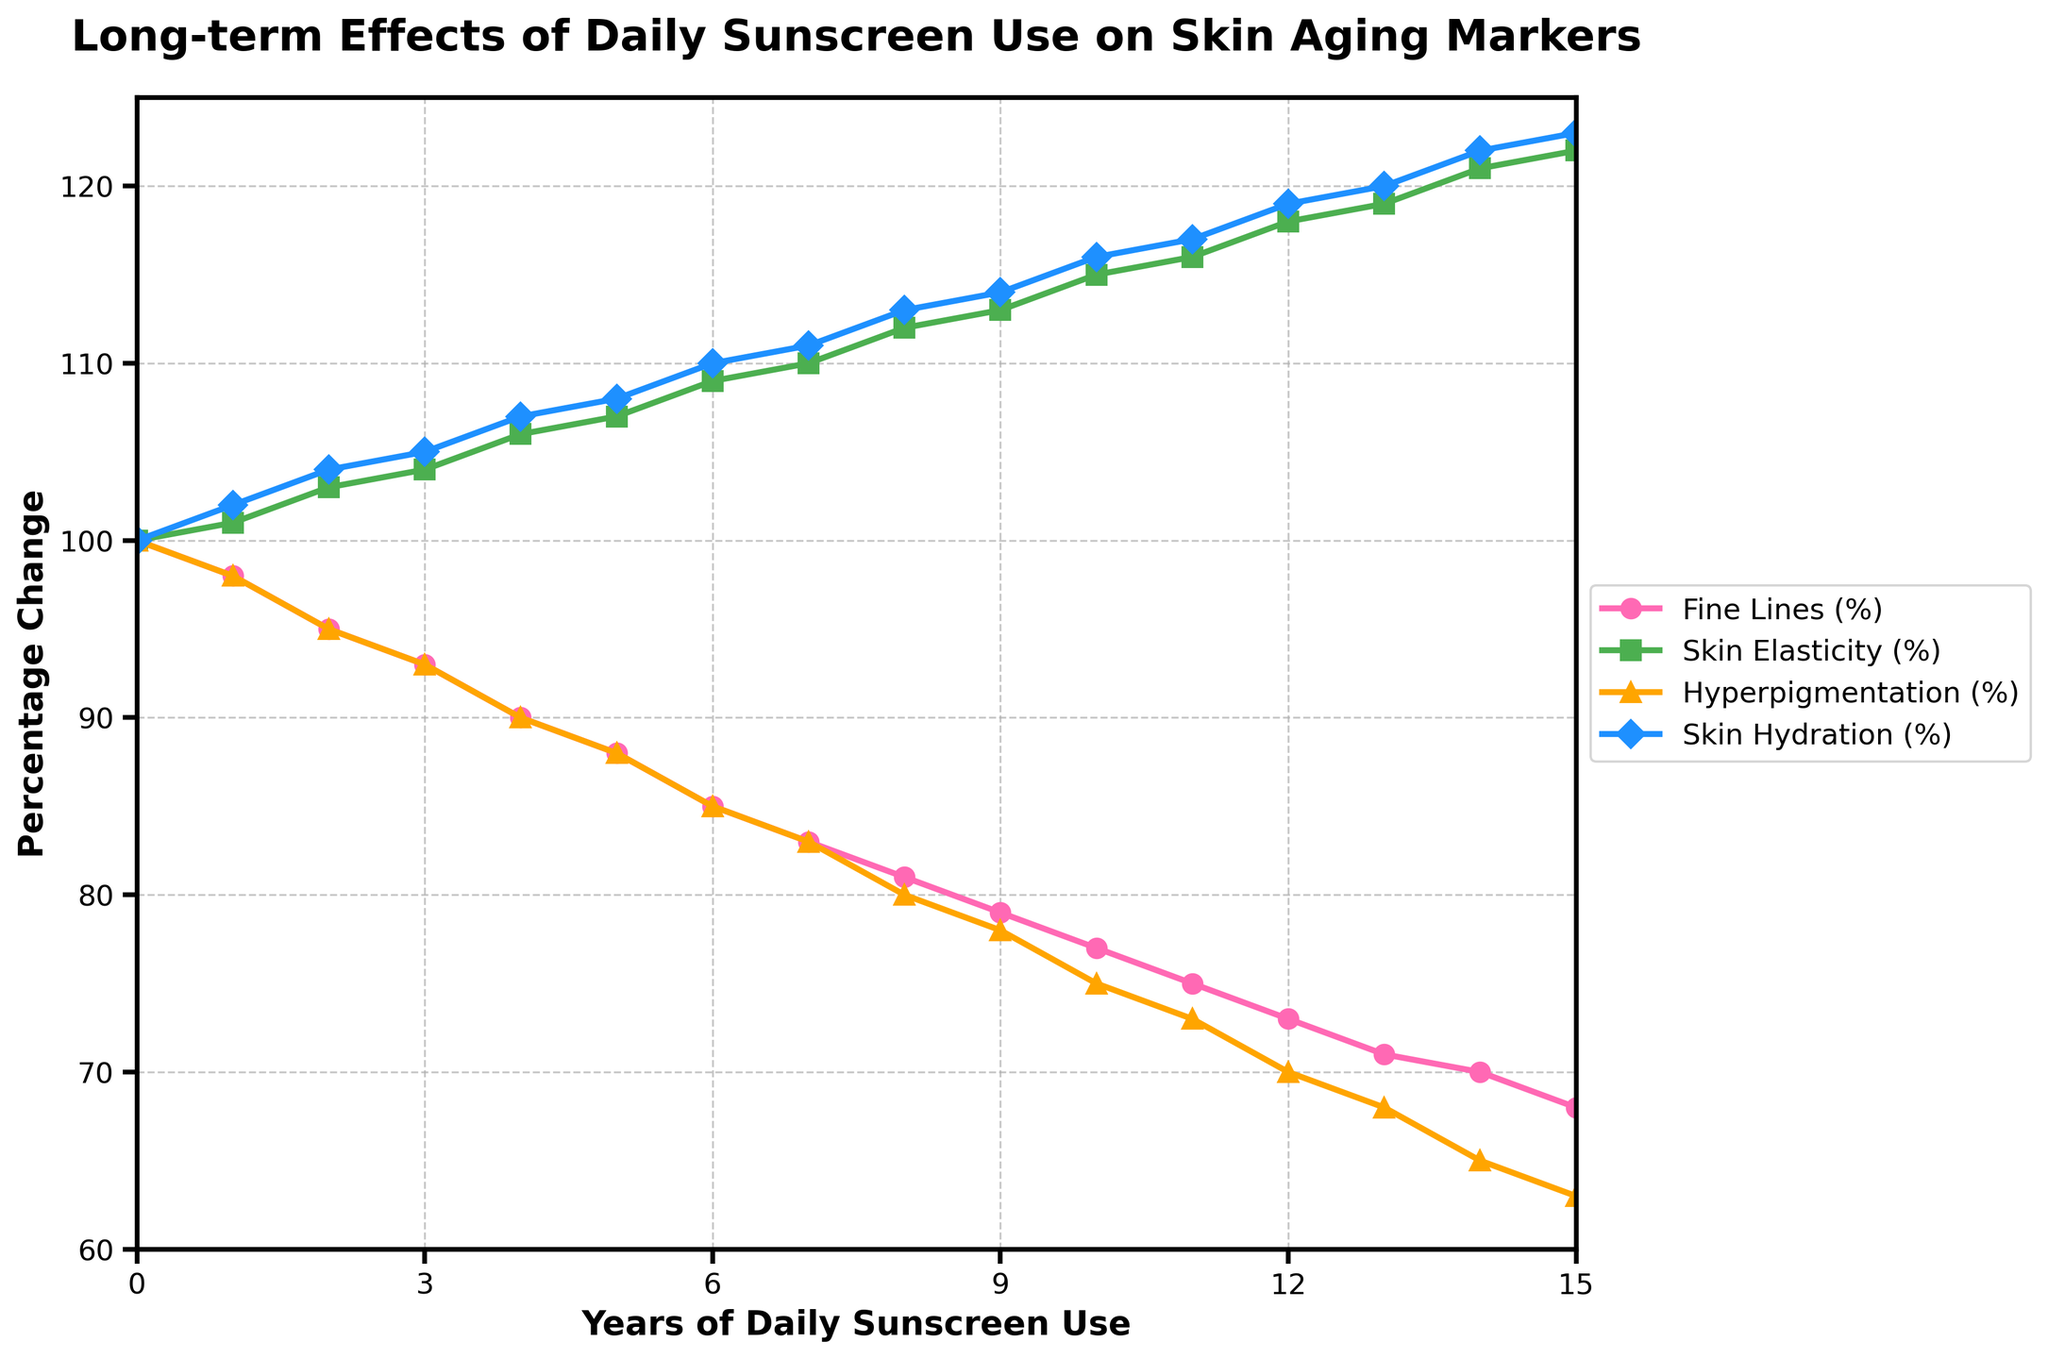What is the initial percentage of Fine Lines at Year 0? At Year 0, the point marked for Fine Lines is at 100%. Simply refer to the point on the Y-axis where the Fine Lines line starts.
Answer: 100 By how many percentage points did Skin Elasticity change from Year 0 to Year 15? The initial Skin Elasticity at Year 0 is 100%, and at Year 15, it is 122%. The change is 122% - 100% = 22 percentage points.
Answer: 22 Which skin marker shows the greatest decline over the 15 years? To determine the greatest decline, compare the initial and final percentage values of all skin markers. Fine Lines drop from 100% to 68% (32 percentage points), Skin Elasticity increases, Hyperpigmentation drops from 100% to 63% (37 percentage points), and Skin Hydration increases. Thus, Hyperpigmentation shows the greatest decline.
Answer: Hyperpigmentation How much does Skin Hydration percentage increase between Year 0 and Year 10? From Year 0 to Year 10, Skin Hydration increases from 100% to 116%. The increase is 116% - 100% = 16%.
Answer: 16 Which skin marker shows the second most significant improvement over 15 years? To find significant improvements, compare the final percentages to the initial ones. Skin Elasticity increases the most (122% - 100% = 22%), and Skin Hydration is next with an increase from 100% to 123% (23%). Therefore, Skin Hydration shows the second most significant improvement.
Answer: Skin Hydration At what year do Fine Lines fall below 90% for the first time? To find this year, look at the Fine Lines' trend. Fine Lines fall below 90% between Year 3 and 4, reaching 90% exactly at Year 4.
Answer: Year 4 Are there any skin markers that never drop below their Year 0 values? By scrutinizing each line graph, Skin Elasticity and Skin Hydration consistently increase over the years. As a result, they never drop below their initial values.
Answer: Skin Elasticity and Skin Hydration What is the average percentage of Fine Lines over the 15 years of daily sunscreen use? Summing up the Fine Lines percentages from Years 0 to 15, we get: 100 + 98 + 95 + 93 + 90 + 88 + 85 + 83 + 81 + 79 + 77 + 75 + 73 + 71 + 70 + 68 = 1246. Average = 1246 / 16 = 77.875%.
Answer: 77.875 From Year 6 to Year 9, which skin marker has the most consistent trend? Analyzing Year 6 to Year 9 values, only Skin Hydration shows a consistent percentage increase each year (110% to 114%). Other markers fluctuate slightly.
Answer: Skin Hydration Between Year 9 and Year 12, which marker sees the most significant percentage decline? Comparing the percentage drops from Year 9 to Year 12, Fine Lines drop from 79% to 73%, Hyperpigmentation drops from 78% to 70%, Skin Elasticity decreases slightly, and Skin Hydration increases. Fine Lines and Hyperpigmentation have the largest declines, but Hyperpigmentation (8 percentage points) declines more than Fine Lines (6 percentage points).
Answer: Hyperpigmentation 